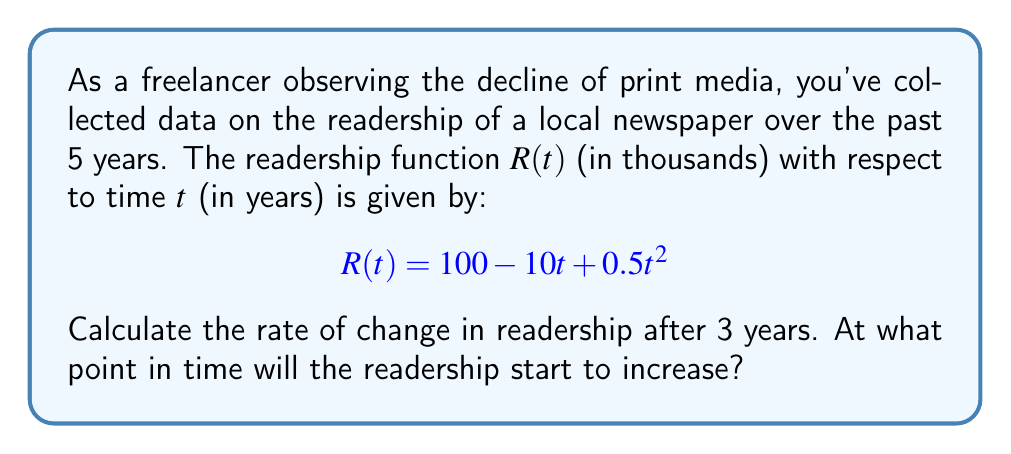Show me your answer to this math problem. To solve this problem, we'll follow these steps:

1. Find the derivative of the readership function $R(t)$:
   $$R'(t) = \frac{d}{dt}(100 - 10t + 0.5t^2) = -10 + t$$

2. Calculate the rate of change after 3 years by evaluating $R'(3)$:
   $$R'(3) = -10 + 3 = -7$$
   This means the readership is decreasing at a rate of 7,000 readers per year after 3 years.

3. To find when the readership starts to increase, we need to find when $R'(t) = 0$:
   $$-10 + t = 0$$
   $$t = 10$$

   After $t = 10$, $R'(t)$ becomes positive, indicating an increase in readership.

4. Verify by checking the sign of $R'(t)$ before and after $t = 10$:
   For $t < 10$, $R'(t) < 0$ (decreasing)
   For $t > 10$, $R'(t) > 0$ (increasing)
Answer: $-7,000$ readers/year; $10$ years 